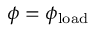Convert formula to latex. <formula><loc_0><loc_0><loc_500><loc_500>\phi = \phi _ { l o a d }</formula> 